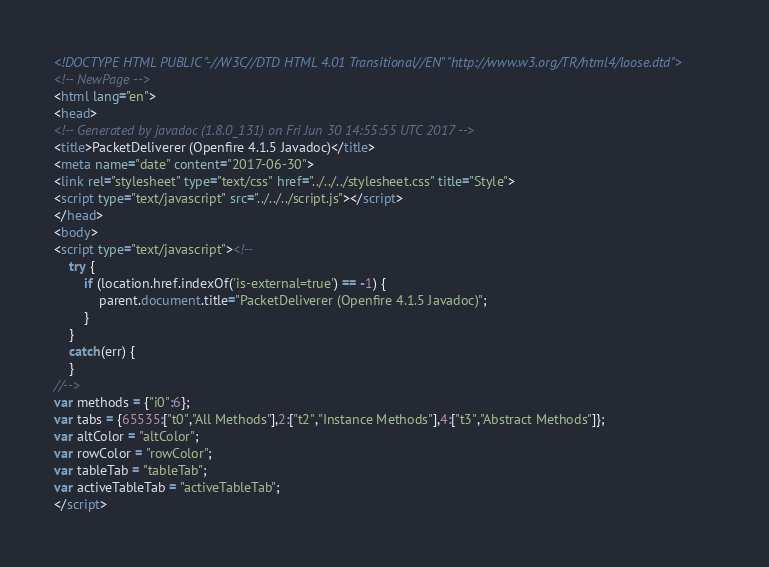<code> <loc_0><loc_0><loc_500><loc_500><_HTML_><!DOCTYPE HTML PUBLIC "-//W3C//DTD HTML 4.01 Transitional//EN" "http://www.w3.org/TR/html4/loose.dtd">
<!-- NewPage -->
<html lang="en">
<head>
<!-- Generated by javadoc (1.8.0_131) on Fri Jun 30 14:55:55 UTC 2017 -->
<title>PacketDeliverer (Openfire 4.1.5 Javadoc)</title>
<meta name="date" content="2017-06-30">
<link rel="stylesheet" type="text/css" href="../../../stylesheet.css" title="Style">
<script type="text/javascript" src="../../../script.js"></script>
</head>
<body>
<script type="text/javascript"><!--
    try {
        if (location.href.indexOf('is-external=true') == -1) {
            parent.document.title="PacketDeliverer (Openfire 4.1.5 Javadoc)";
        }
    }
    catch(err) {
    }
//-->
var methods = {"i0":6};
var tabs = {65535:["t0","All Methods"],2:["t2","Instance Methods"],4:["t3","Abstract Methods"]};
var altColor = "altColor";
var rowColor = "rowColor";
var tableTab = "tableTab";
var activeTableTab = "activeTableTab";
</script></code> 